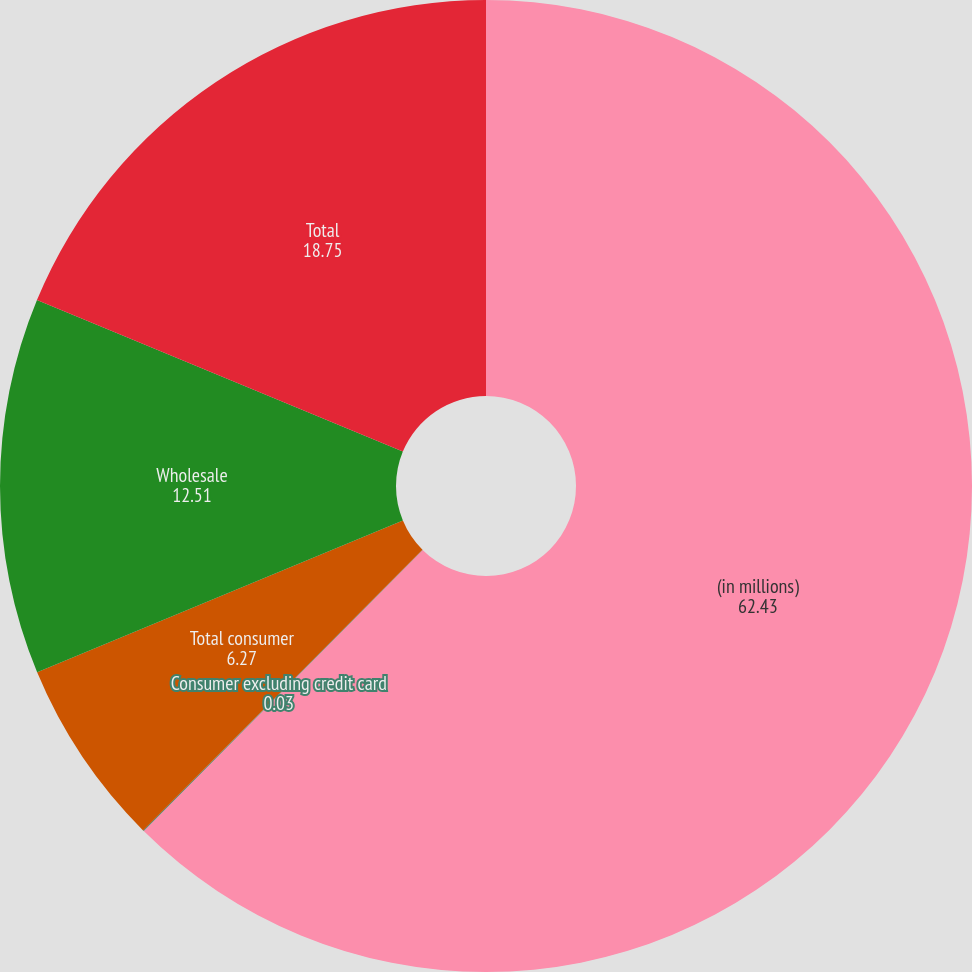Convert chart to OTSL. <chart><loc_0><loc_0><loc_500><loc_500><pie_chart><fcel>(in millions)<fcel>Consumer excluding credit card<fcel>Total consumer<fcel>Wholesale<fcel>Total<nl><fcel>62.43%<fcel>0.03%<fcel>6.27%<fcel>12.51%<fcel>18.75%<nl></chart> 